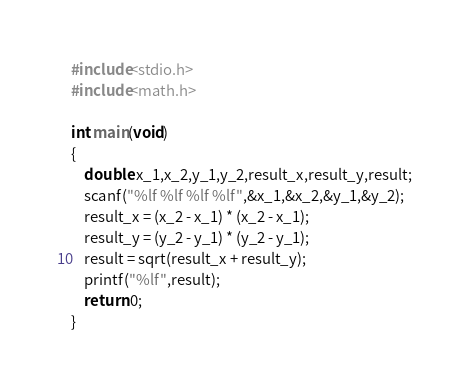<code> <loc_0><loc_0><loc_500><loc_500><_C_>#include<stdio.h>
#include<math.h>

int main(void)
{
	double x_1,x_2,y_1,y_2,result_x,result_y,result;
	scanf("%lf %lf %lf %lf",&x_1,&x_2,&y_1,&y_2);
	result_x = (x_2 - x_1) * (x_2 - x_1);
	result_y = (y_2 - y_1) * (y_2 - y_1);
	result = sqrt(result_x + result_y);
	printf("%lf",result);
	return 0;
}</code> 